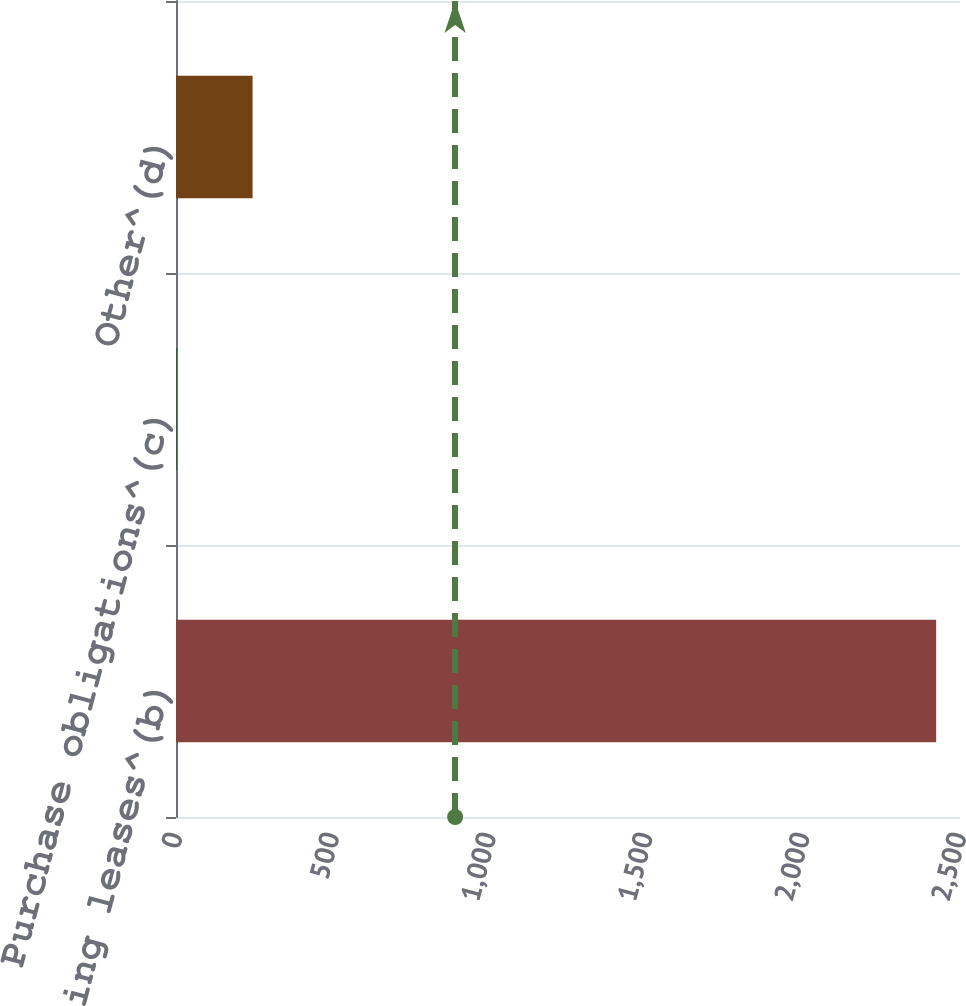<chart> <loc_0><loc_0><loc_500><loc_500><bar_chart><fcel>Operating leases^(b)<fcel>Purchase obligations^(c)<fcel>Other^(d)<nl><fcel>2424<fcel>2<fcel>244.2<nl></chart> 